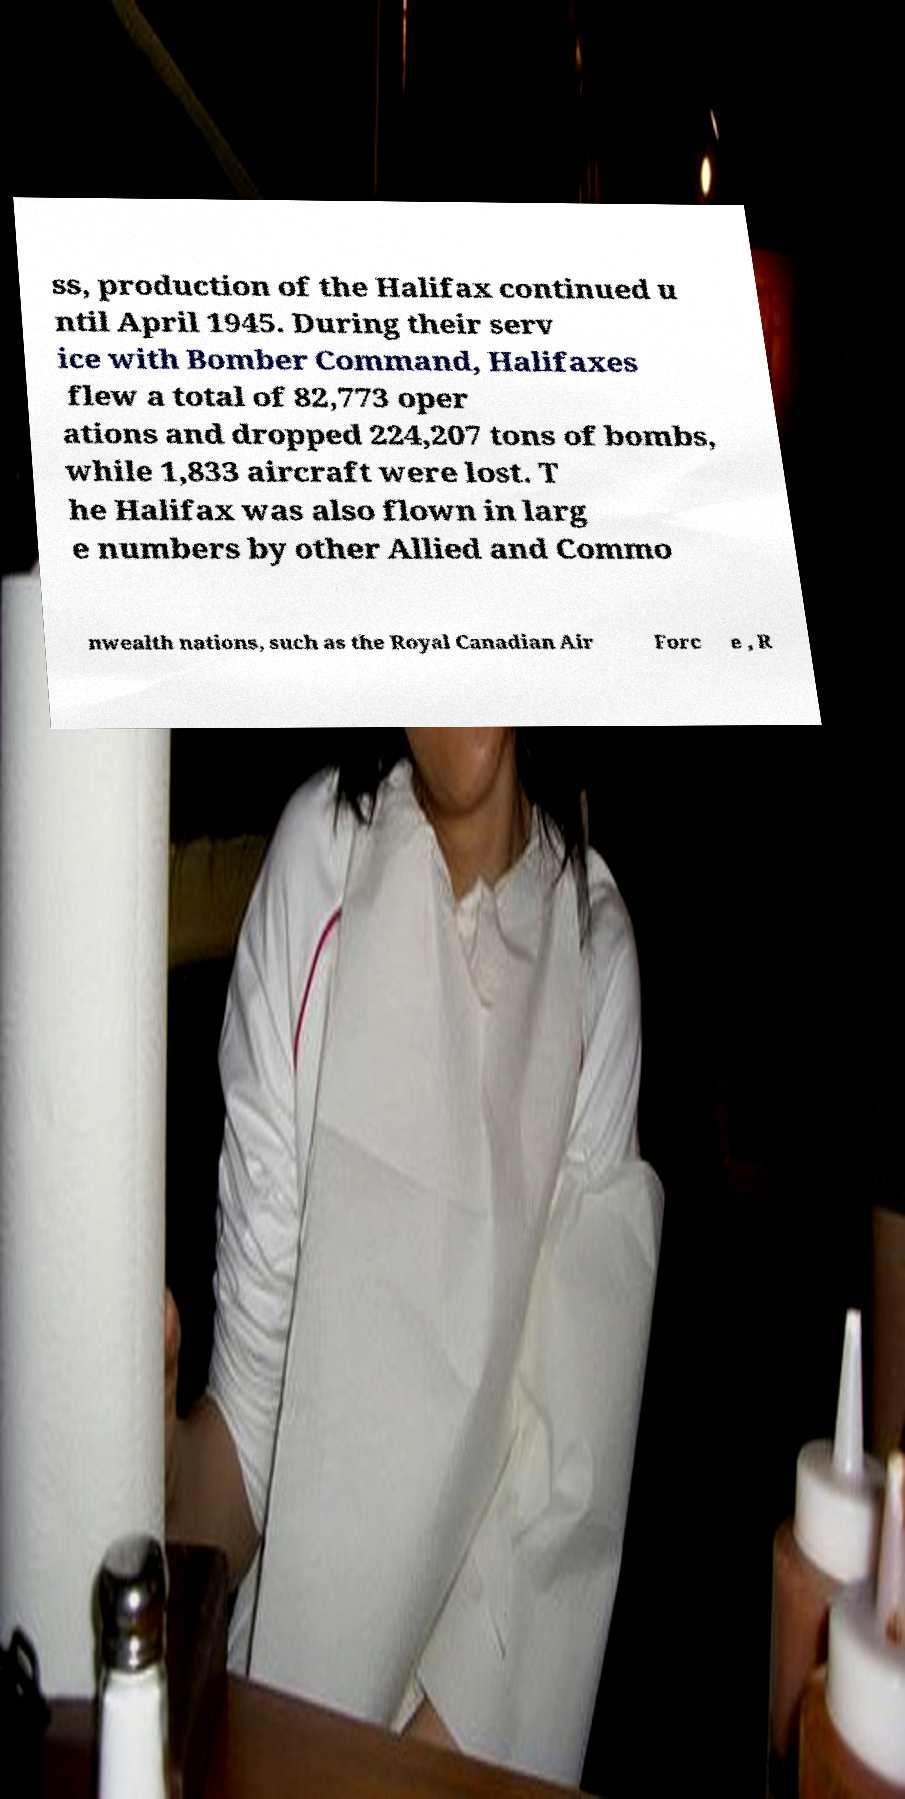What messages or text are displayed in this image? I need them in a readable, typed format. ss, production of the Halifax continued u ntil April 1945. During their serv ice with Bomber Command, Halifaxes flew a total of 82,773 oper ations and dropped 224,207 tons of bombs, while 1,833 aircraft were lost. T he Halifax was also flown in larg e numbers by other Allied and Commo nwealth nations, such as the Royal Canadian Air Forc e , R 